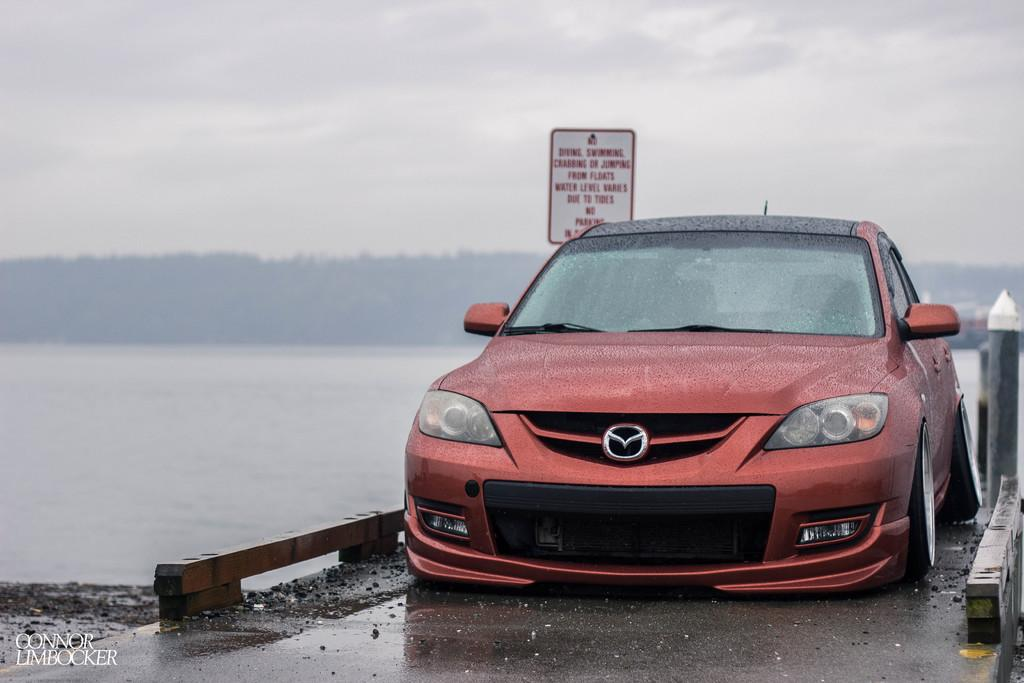What is on the bridge in the image? There is a car on the bridge in the image. What can be seen below the bridge? There is water visible in the image. What object is present in the image besides the car and water? There is a board in the image. What is visible in the background of the image? The sky is visible in the background of the image. What sound can be heard coming from the tramp in the image? There is no tramp present in the image, so no sound can be heard from it. 